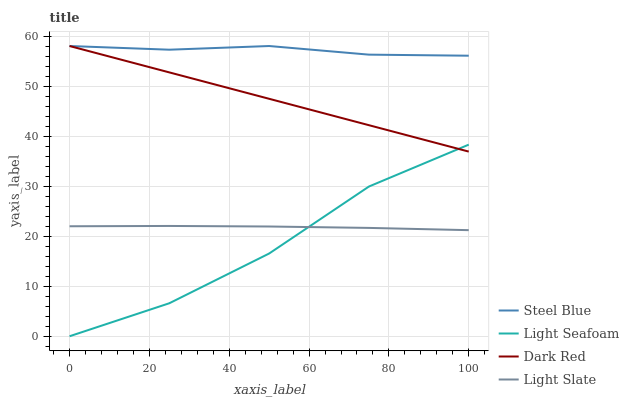Does Light Seafoam have the minimum area under the curve?
Answer yes or no. Yes. Does Steel Blue have the maximum area under the curve?
Answer yes or no. Yes. Does Dark Red have the minimum area under the curve?
Answer yes or no. No. Does Dark Red have the maximum area under the curve?
Answer yes or no. No. Is Dark Red the smoothest?
Answer yes or no. Yes. Is Light Seafoam the roughest?
Answer yes or no. Yes. Is Light Seafoam the smoothest?
Answer yes or no. No. Is Dark Red the roughest?
Answer yes or no. No. Does Dark Red have the lowest value?
Answer yes or no. No. Does Light Seafoam have the highest value?
Answer yes or no. No. Is Light Slate less than Dark Red?
Answer yes or no. Yes. Is Dark Red greater than Light Slate?
Answer yes or no. Yes. Does Light Slate intersect Dark Red?
Answer yes or no. No. 